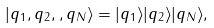Convert formula to latex. <formula><loc_0><loc_0><loc_500><loc_500>| q _ { 1 } , q _ { 2 } , , q _ { N } \rangle = | q _ { 1 } \rangle | q _ { 2 } \rangle | q _ { N } \rangle ,</formula> 